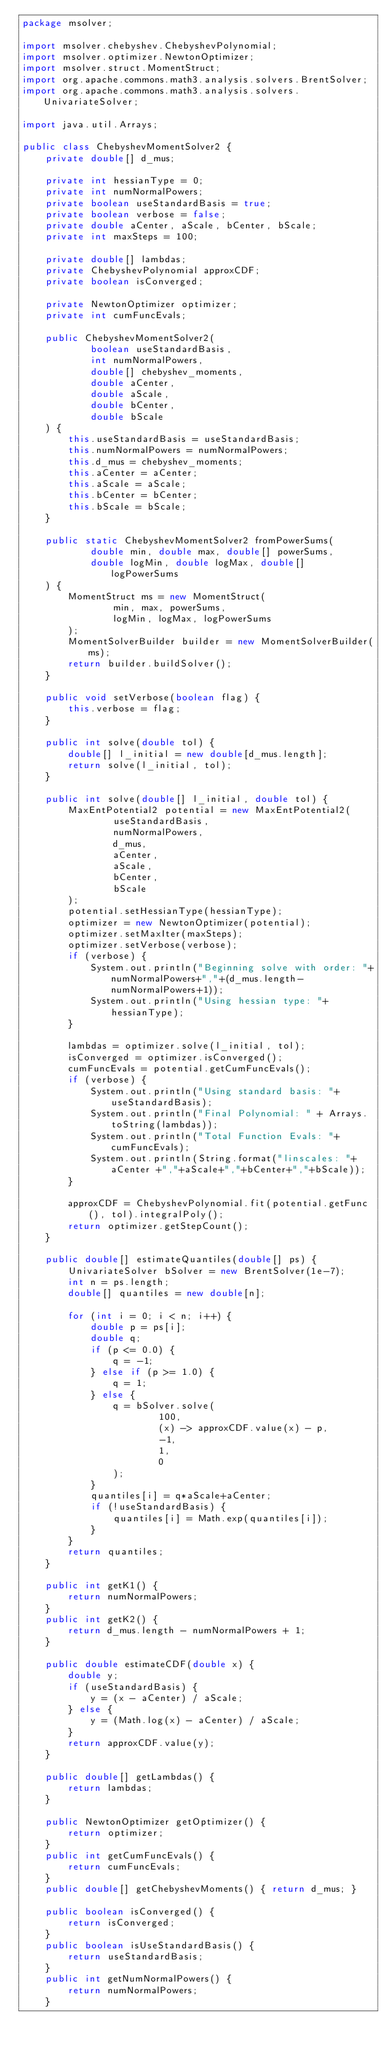Convert code to text. <code><loc_0><loc_0><loc_500><loc_500><_Java_>package msolver;

import msolver.chebyshev.ChebyshevPolynomial;
import msolver.optimizer.NewtonOptimizer;
import msolver.struct.MomentStruct;
import org.apache.commons.math3.analysis.solvers.BrentSolver;
import org.apache.commons.math3.analysis.solvers.UnivariateSolver;

import java.util.Arrays;

public class ChebyshevMomentSolver2 {
    private double[] d_mus;

    private int hessianType = 0;
    private int numNormalPowers;
    private boolean useStandardBasis = true;
    private boolean verbose = false;
    private double aCenter, aScale, bCenter, bScale;
    private int maxSteps = 100;

    private double[] lambdas;
    private ChebyshevPolynomial approxCDF;
    private boolean isConverged;

    private NewtonOptimizer optimizer;
    private int cumFuncEvals;

    public ChebyshevMomentSolver2(
            boolean useStandardBasis,
            int numNormalPowers,
            double[] chebyshev_moments,
            double aCenter,
            double aScale,
            double bCenter,
            double bScale
    ) {
        this.useStandardBasis = useStandardBasis;
        this.numNormalPowers = numNormalPowers;
        this.d_mus = chebyshev_moments;
        this.aCenter = aCenter;
        this.aScale = aScale;
        this.bCenter = bCenter;
        this.bScale = bScale;
    }

    public static ChebyshevMomentSolver2 fromPowerSums(
            double min, double max, double[] powerSums,
            double logMin, double logMax, double[] logPowerSums
    ) {
        MomentStruct ms = new MomentStruct(
                min, max, powerSums,
                logMin, logMax, logPowerSums
        );
        MomentSolverBuilder builder = new MomentSolverBuilder(ms);
        return builder.buildSolver();
    }

    public void setVerbose(boolean flag) {
        this.verbose = flag;
    }

    public int solve(double tol) {
        double[] l_initial = new double[d_mus.length];
        return solve(l_initial, tol);
    }

    public int solve(double[] l_initial, double tol) {
        MaxEntPotential2 potential = new MaxEntPotential2(
                useStandardBasis,
                numNormalPowers,
                d_mus,
                aCenter,
                aScale,
                bCenter,
                bScale
        );
        potential.setHessianType(hessianType);
        optimizer = new NewtonOptimizer(potential);
        optimizer.setMaxIter(maxSteps);
        optimizer.setVerbose(verbose);
        if (verbose) {
            System.out.println("Beginning solve with order: "+numNormalPowers+","+(d_mus.length-numNormalPowers+1));
            System.out.println("Using hessian type: "+hessianType);
        }

        lambdas = optimizer.solve(l_initial, tol);
        isConverged = optimizer.isConverged();
        cumFuncEvals = potential.getCumFuncEvals();
        if (verbose) {
            System.out.println("Using standard basis: "+ useStandardBasis);
            System.out.println("Final Polynomial: " + Arrays.toString(lambdas));
            System.out.println("Total Function Evals: "+cumFuncEvals);
            System.out.println(String.format("linscales: "+ aCenter +","+aScale+","+bCenter+","+bScale));
        }

        approxCDF = ChebyshevPolynomial.fit(potential.getFunc(), tol).integralPoly();
        return optimizer.getStepCount();
    }

    public double[] estimateQuantiles(double[] ps) {
        UnivariateSolver bSolver = new BrentSolver(1e-7);
        int n = ps.length;
        double[] quantiles = new double[n];

        for (int i = 0; i < n; i++) {
            double p = ps[i];
            double q;
            if (p <= 0.0) {
                q = -1;
            } else if (p >= 1.0) {
                q = 1;
            } else {
                q = bSolver.solve(
                        100,
                        (x) -> approxCDF.value(x) - p,
                        -1,
                        1,
                        0
                );
            }
            quantiles[i] = q*aScale+aCenter;
            if (!useStandardBasis) {
                quantiles[i] = Math.exp(quantiles[i]);
            }
        }
        return quantiles;
    }

    public int getK1() {
        return numNormalPowers;
    }
    public int getK2() {
        return d_mus.length - numNormalPowers + 1;
    }

    public double estimateCDF(double x) {
        double y;
        if (useStandardBasis) {
            y = (x - aCenter) / aScale;
        } else {
            y = (Math.log(x) - aCenter) / aScale;
        }
        return approxCDF.value(y);
    }

    public double[] getLambdas() {
        return lambdas;
    }

    public NewtonOptimizer getOptimizer() {
        return optimizer;
    }
    public int getCumFuncEvals() {
        return cumFuncEvals;
    }
    public double[] getChebyshevMoments() { return d_mus; }

    public boolean isConverged() {
        return isConverged;
    }
    public boolean isUseStandardBasis() {
        return useStandardBasis;
    }
    public int getNumNormalPowers() {
        return numNormalPowers;
    }
</code> 